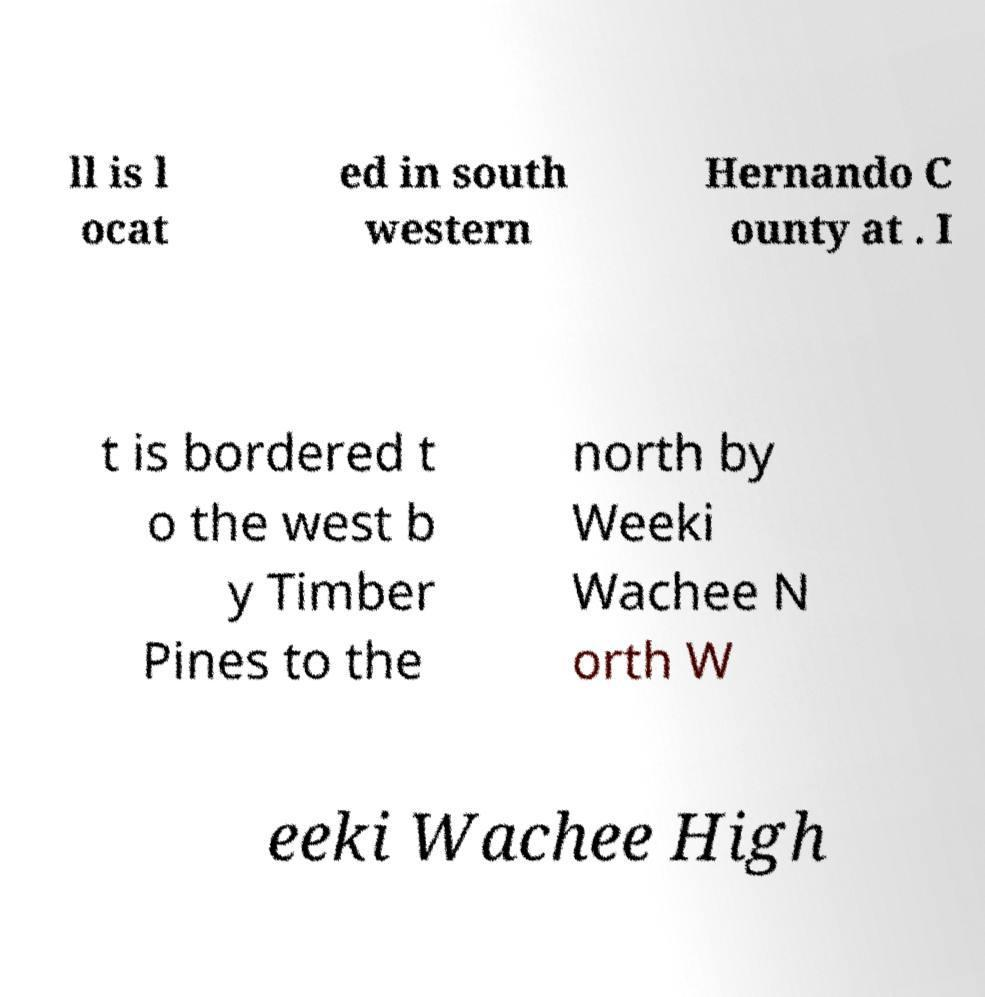Could you assist in decoding the text presented in this image and type it out clearly? ll is l ocat ed in south western Hernando C ounty at . I t is bordered t o the west b y Timber Pines to the north by Weeki Wachee N orth W eeki Wachee High 